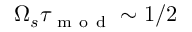Convert formula to latex. <formula><loc_0><loc_0><loc_500><loc_500>\Omega _ { s } \tau _ { m o d } \sim 1 / 2</formula> 